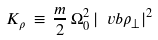<formula> <loc_0><loc_0><loc_500><loc_500>K _ { \rho } \, \equiv \, \frac { m } { 2 } \, \Omega _ { 0 } ^ { 2 } \, | \ v b { \rho } _ { \bot } | ^ { 2 }</formula> 